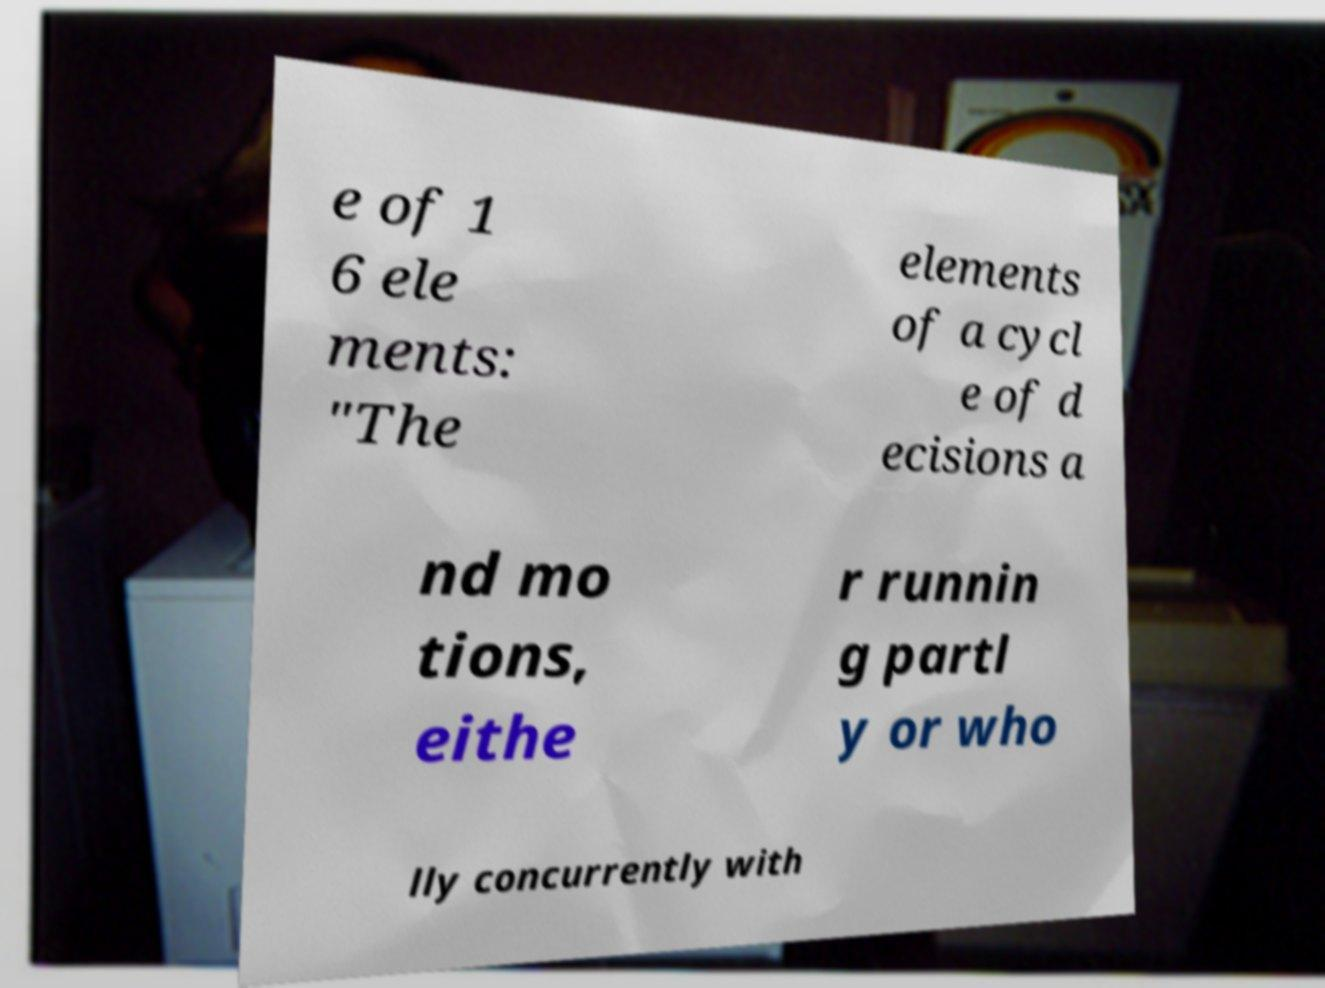There's text embedded in this image that I need extracted. Can you transcribe it verbatim? e of 1 6 ele ments: "The elements of a cycl e of d ecisions a nd mo tions, eithe r runnin g partl y or who lly concurrently with 